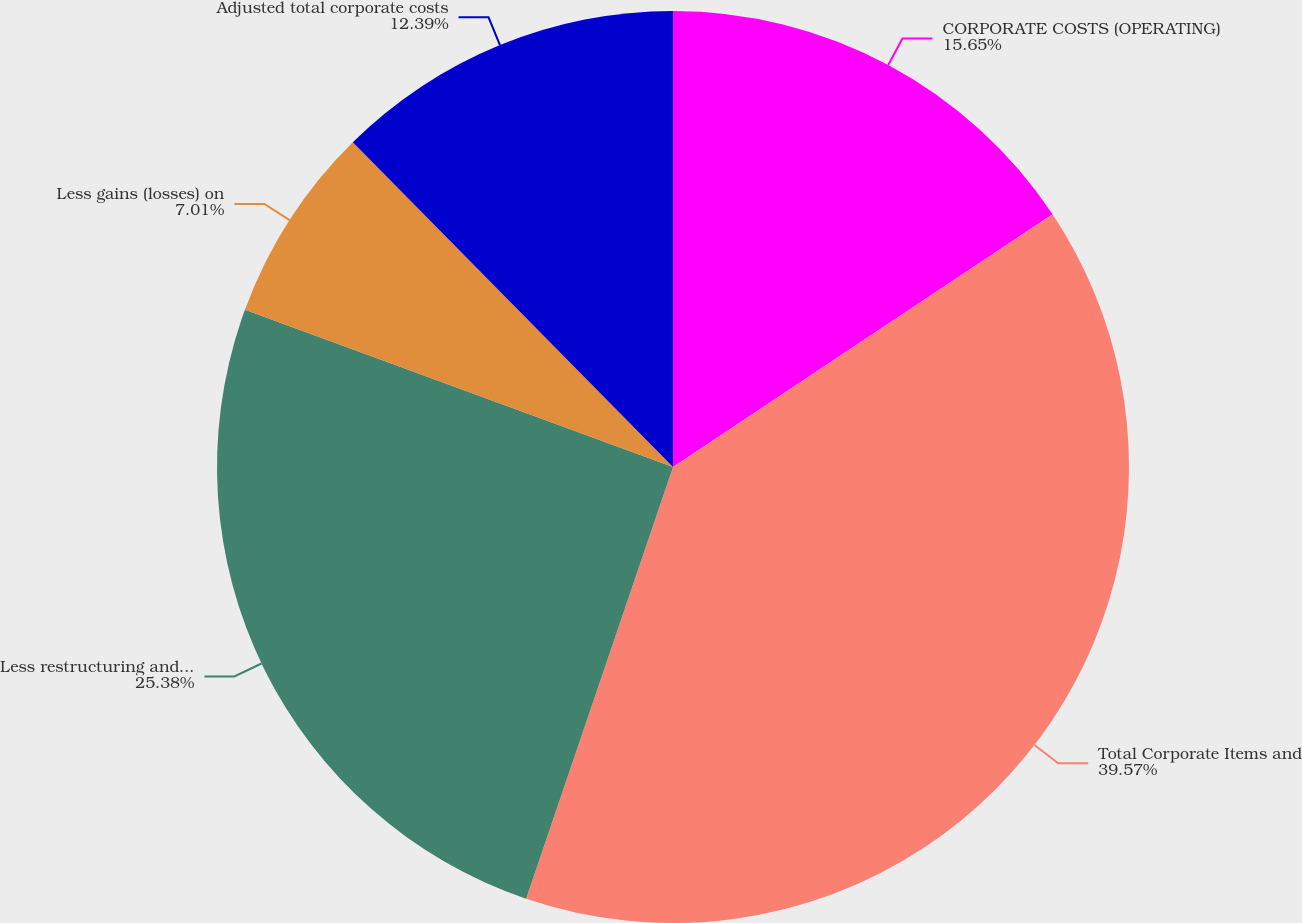Convert chart. <chart><loc_0><loc_0><loc_500><loc_500><pie_chart><fcel>CORPORATE COSTS (OPERATING)<fcel>Total Corporate Items and<fcel>Less restructuring and other<fcel>Less gains (losses) on<fcel>Adjusted total corporate costs<nl><fcel>15.65%<fcel>39.57%<fcel>25.38%<fcel>7.01%<fcel>12.39%<nl></chart> 